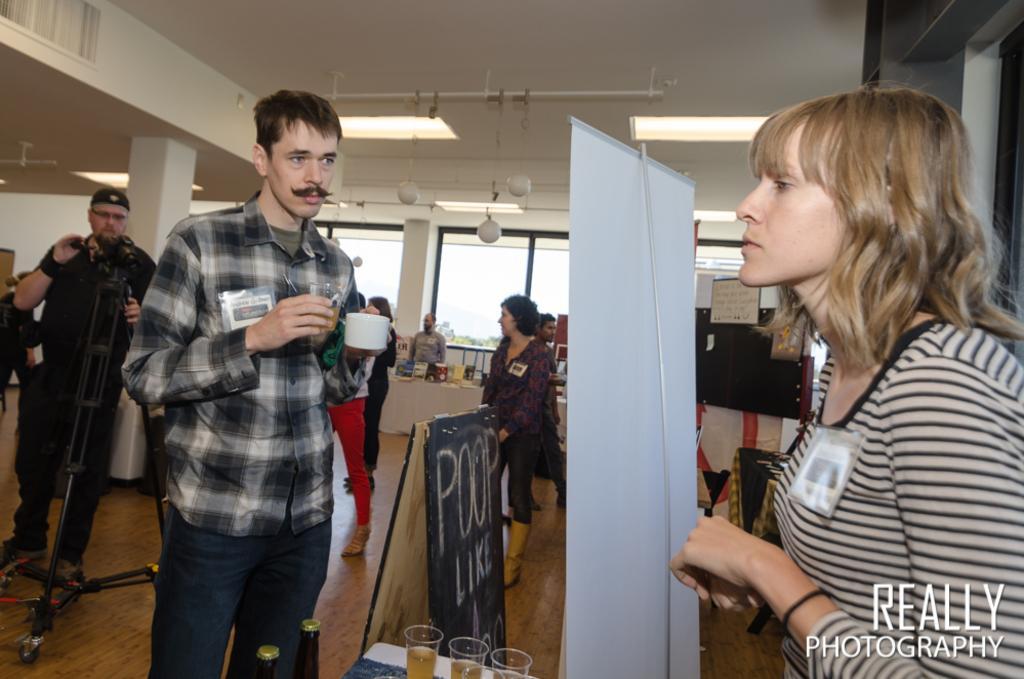Could you give a brief overview of what you see in this image? In this image I can see few persons are standing on the floor and they are holding few objects in their hands. I can see a board, a banner and in the background I can see a pillar, the ceiling, few lights to the ceiling, the wall and the glass window through which I can see few trees and the sky. 